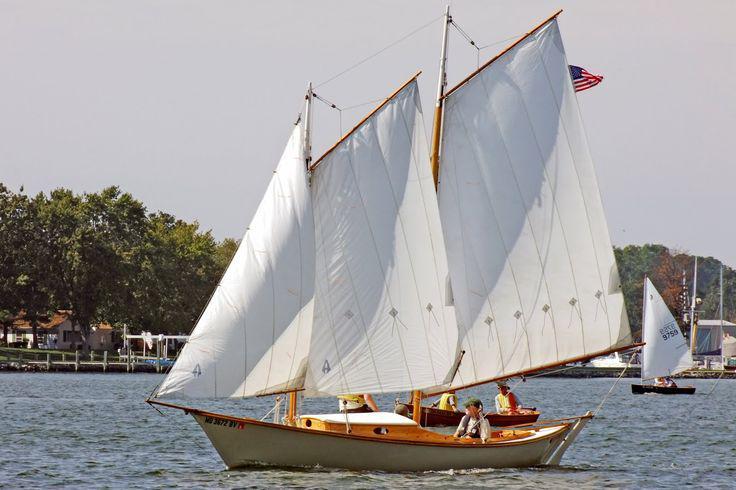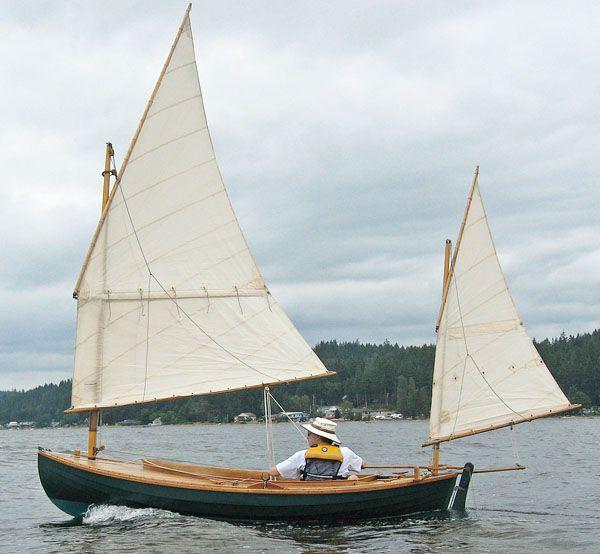The first image is the image on the left, the second image is the image on the right. Examine the images to the left and right. Is the description "There are no more than three sails." accurate? Answer yes or no. No. 